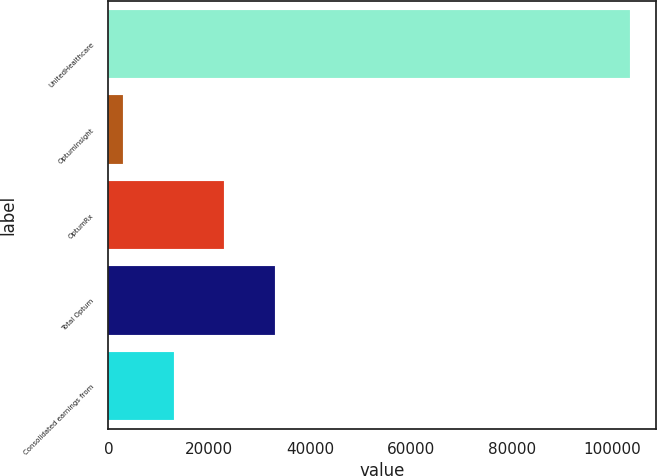Convert chart to OTSL. <chart><loc_0><loc_0><loc_500><loc_500><bar_chart><fcel>UnitedHealthcare<fcel>OptumInsight<fcel>OptumRx<fcel>Total Optum<fcel>Consolidated earnings from<nl><fcel>103419<fcel>2882<fcel>22989.4<fcel>33043.1<fcel>12935.7<nl></chart> 